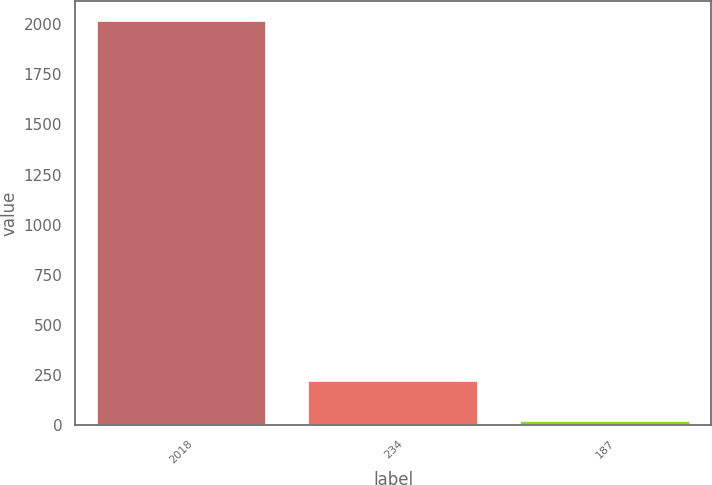<chart> <loc_0><loc_0><loc_500><loc_500><bar_chart><fcel>2018<fcel>234<fcel>187<nl><fcel>2017<fcel>219.79<fcel>20.1<nl></chart> 